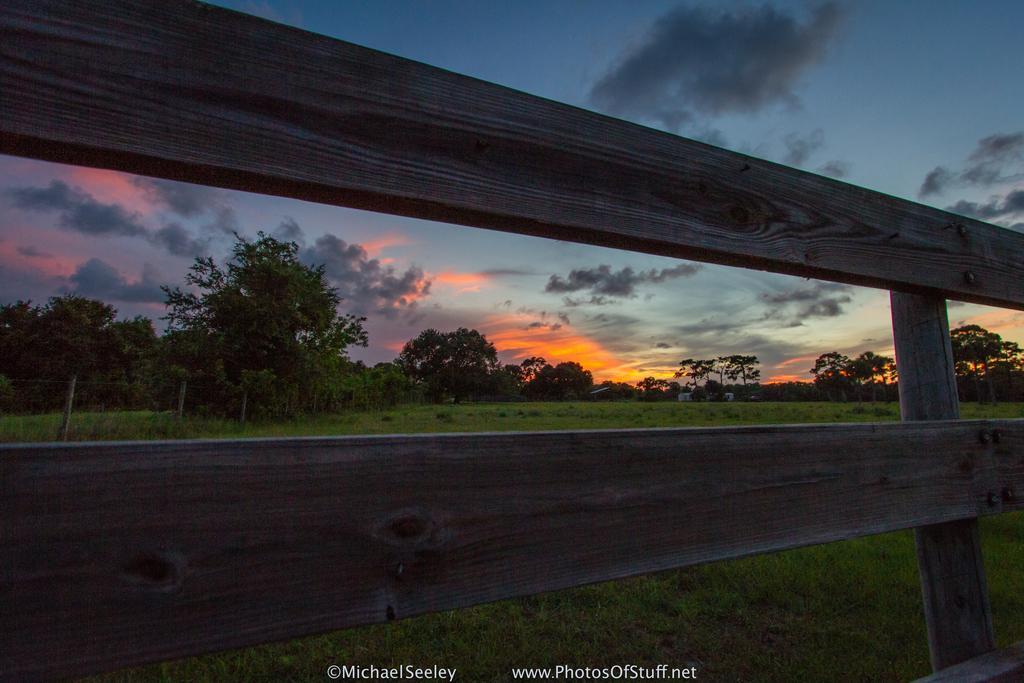In one or two sentences, can you explain what this image depicts? In this image we can see a fencing, there are trees, there is a grass, the sky is cloudy. 